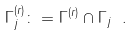Convert formula to latex. <formula><loc_0><loc_0><loc_500><loc_500>\Gamma _ { j } ^ { ( r ) } \colon = \Gamma ^ { ( r ) } \cap \Gamma _ { j } \ .</formula> 